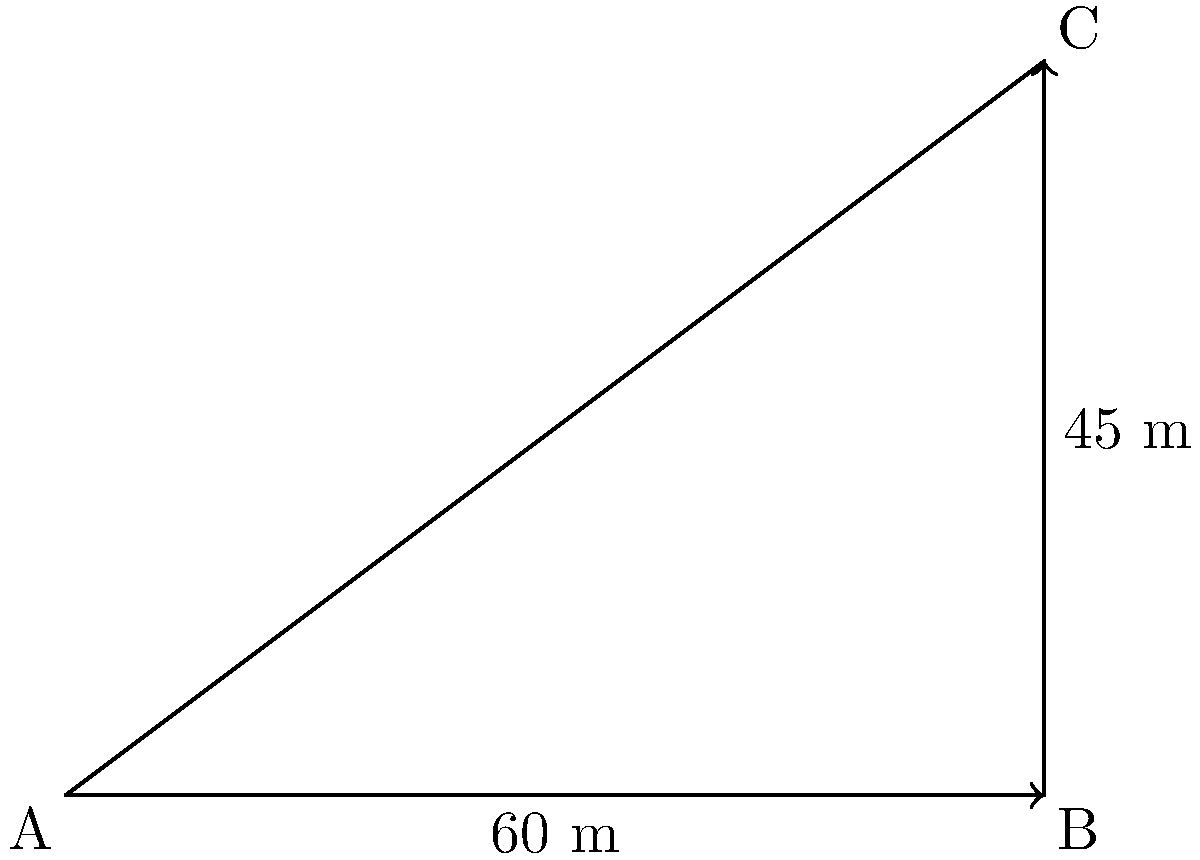As a software architect optimizing a Python application for 3D rendering, you need to calculate the angle of elevation for proper perspective. Given a building with a height of 45 meters and an observer standing 60 meters away from its base, determine the angle of elevation (θ) in degrees. Round your answer to two decimal places. To solve this problem, we'll use trigonometry, specifically the tangent function. Here's a step-by-step approach:

1. Identify the triangle: We have a right-angled triangle where:
   - The adjacent side (distance from the observer to the building's base) is 60 meters.
   - The opposite side (height of the building) is 45 meters.
   - We need to find the angle θ.

2. Recall the tangent function: $\tan(\theta) = \frac{\text{opposite}}{\text{adjacent}}$

3. Substitute the known values:
   $\tan(\theta) = \frac{45}{60}$

4. Simplify:
   $\tan(\theta) = \frac{3}{4} = 0.75$

5. To find θ, we need to use the inverse tangent (arctan or $\tan^{-1}$):
   $\theta = \tan^{-1}(0.75)$

6. Calculate using a scientific calculator or Python's math library:
   $\theta \approx 36.8698976458$ degrees

7. Round to two decimal places:
   $\theta \approx 36.87$ degrees

In Python, you could implement this calculation as:

```python
import math

height = 45
distance = 60
angle_rad = math.atan(height / distance)
angle_deg = math.degrees(angle_rad)
result = round(angle_deg, 2)
```

This approach ensures efficient computation and accurate results, which is crucial for scalable 3D rendering applications.
Answer: $36.87^\circ$ 